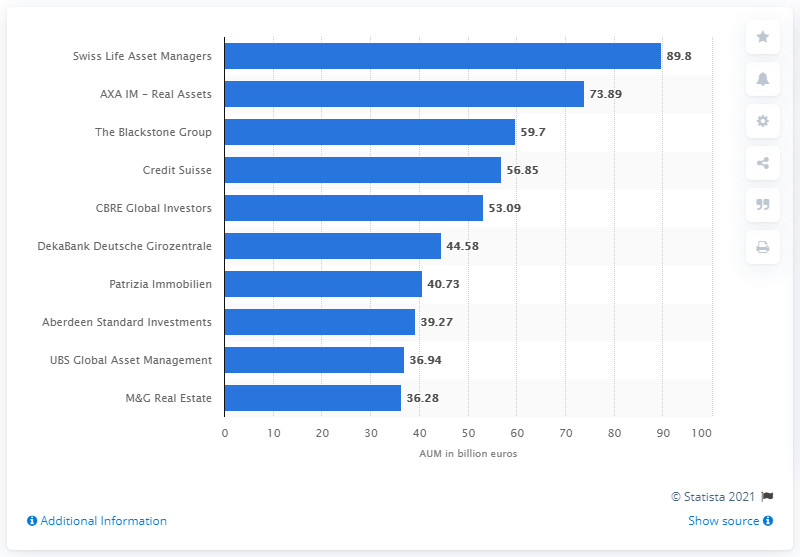Identify some key points in this picture. As of the end of 2021, the assets under management (AUM) of Swiss Life AM accounted for approximately 89.8%. 